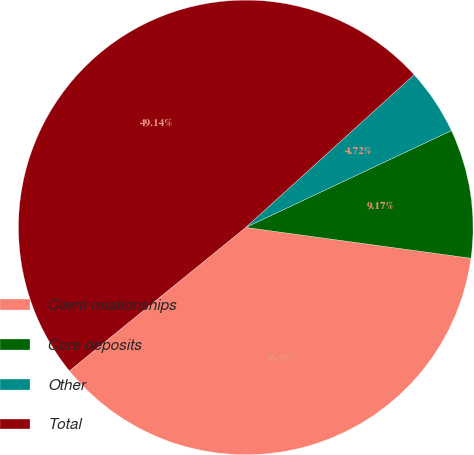<chart> <loc_0><loc_0><loc_500><loc_500><pie_chart><fcel>Client relationships<fcel>Core deposits<fcel>Other<fcel>Total<nl><fcel>36.97%<fcel>9.17%<fcel>4.72%<fcel>49.14%<nl></chart> 